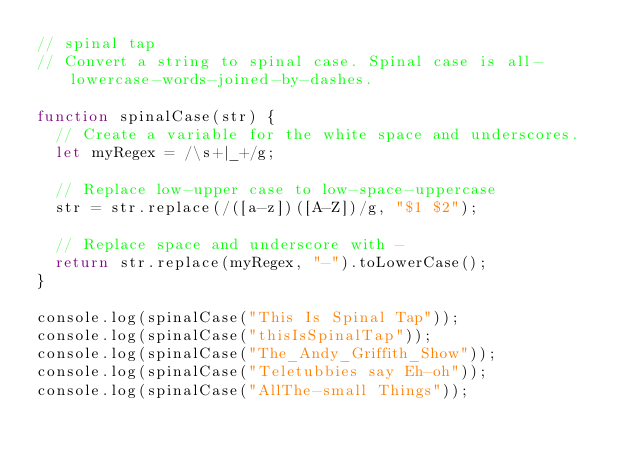<code> <loc_0><loc_0><loc_500><loc_500><_JavaScript_>// spinal tap
// Convert a string to spinal case. Spinal case is all-lowercase-words-joined-by-dashes.

function spinalCase(str) {
	// Create a variable for the white space and underscores.
	let myRegex = /\s+|_+/g;

	// Replace low-upper case to low-space-uppercase
	str = str.replace(/([a-z])([A-Z])/g, "$1 $2");
	
	// Replace space and underscore with -
	return str.replace(myRegex, "-").toLowerCase();
}

console.log(spinalCase("This Is Spinal Tap"));
console.log(spinalCase("thisIsSpinalTap"));
console.log(spinalCase("The_Andy_Griffith_Show"));
console.log(spinalCase("Teletubbies say Eh-oh"));
console.log(spinalCase("AllThe-small Things"));
</code> 